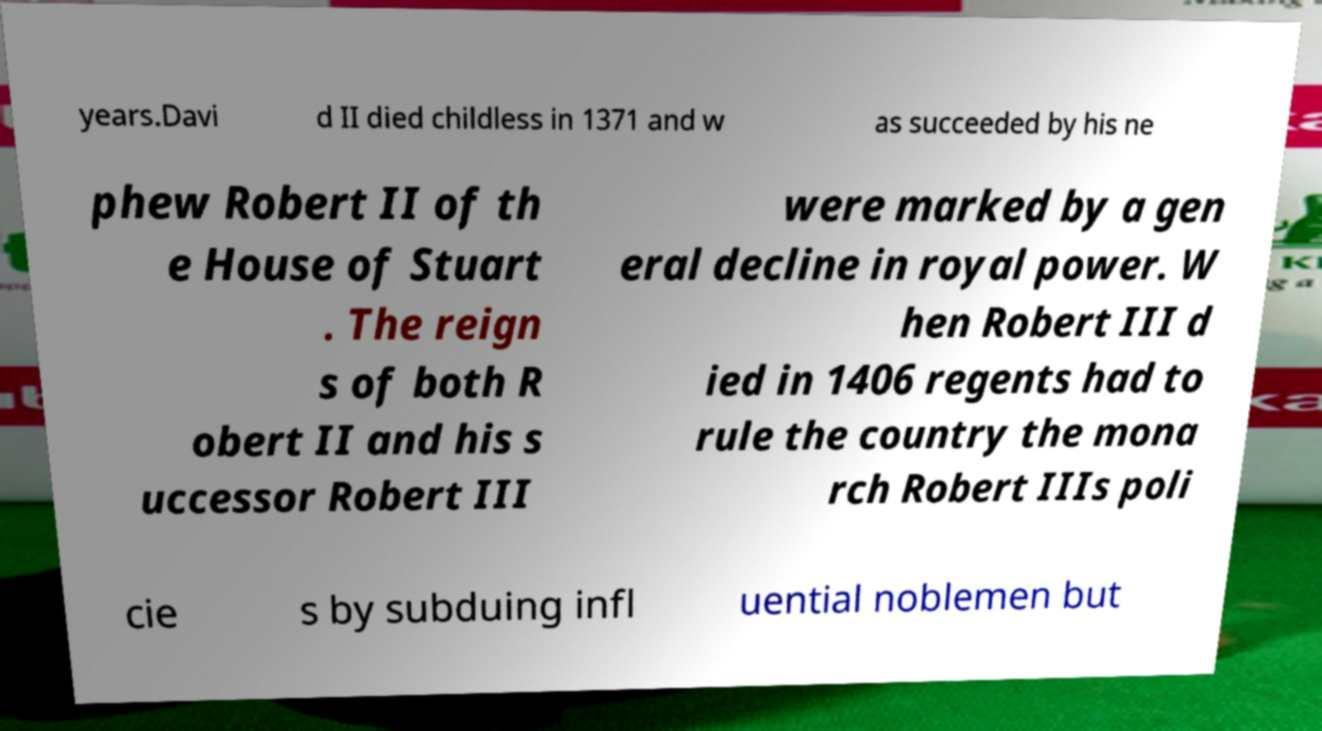Could you extract and type out the text from this image? years.Davi d II died childless in 1371 and w as succeeded by his ne phew Robert II of th e House of Stuart . The reign s of both R obert II and his s uccessor Robert III were marked by a gen eral decline in royal power. W hen Robert III d ied in 1406 regents had to rule the country the mona rch Robert IIIs poli cie s by subduing infl uential noblemen but 